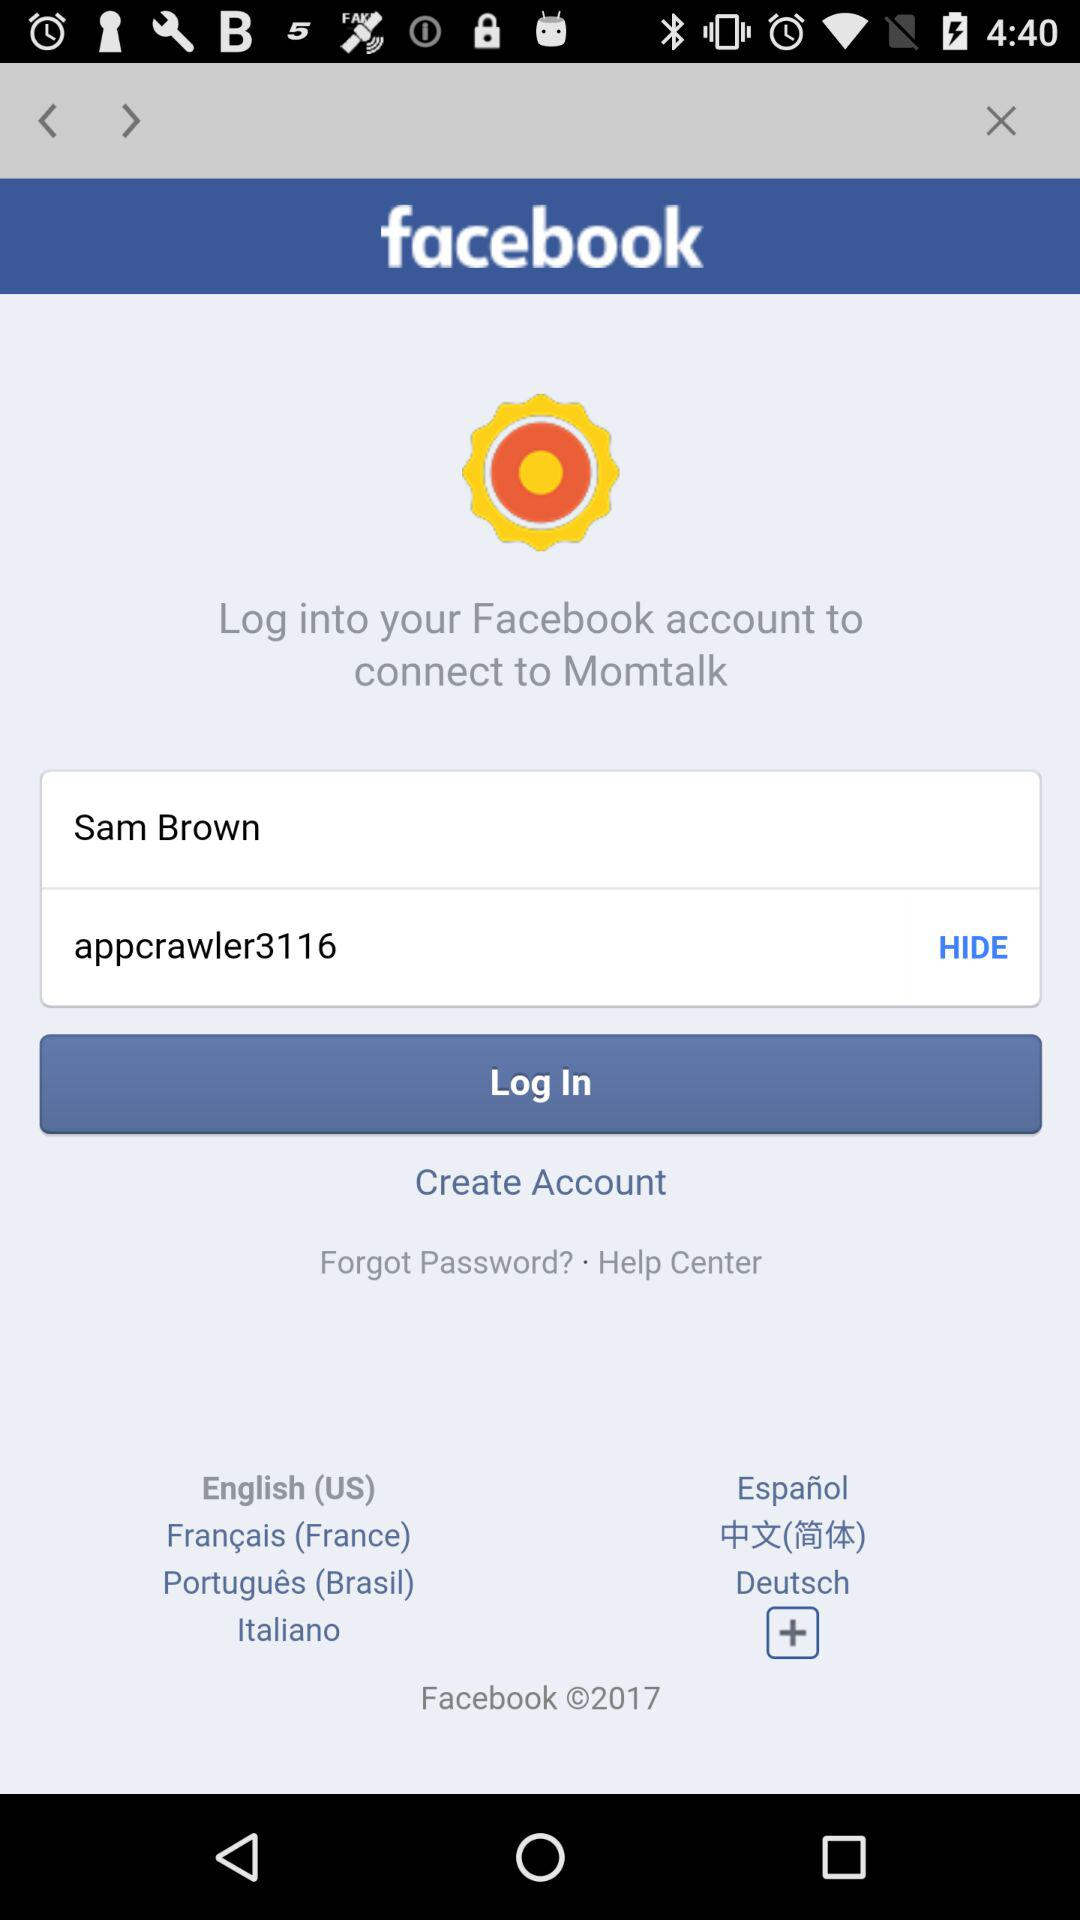What app can we connect to via "facebook"? You can connect to "Momtalk" via "facebook". 